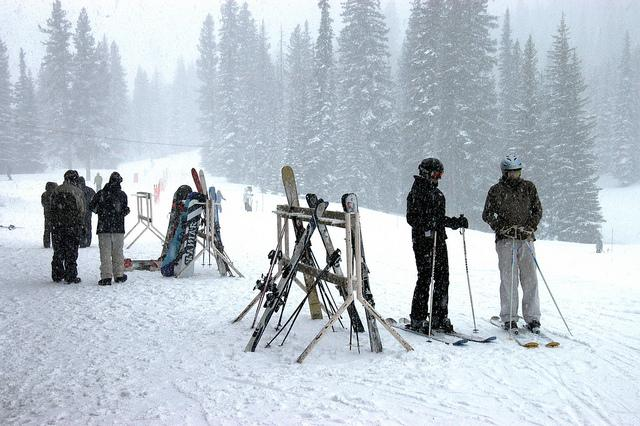What could potentially impede their vision shortly? Please explain your reasoning. snow storm. It is snowing and they are about to ski. 